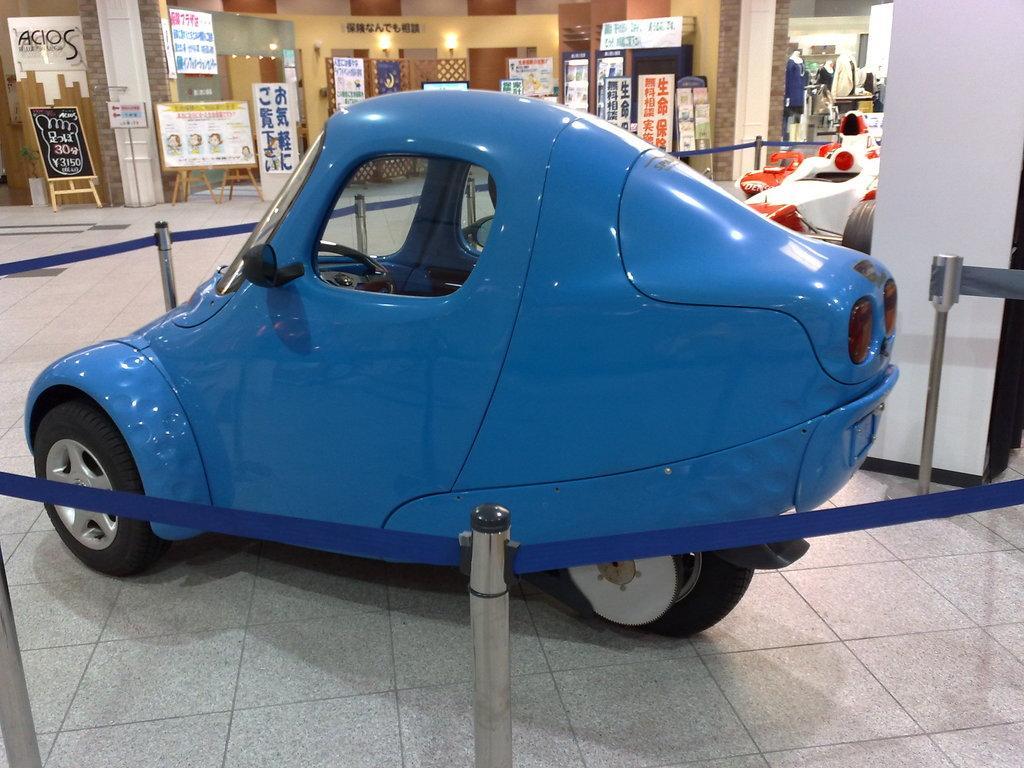How would you summarize this image in a sentence or two? In this image there is a car on a floor around the car there is a railing, in the background there are boards on that boards there is some text and there are shops. 